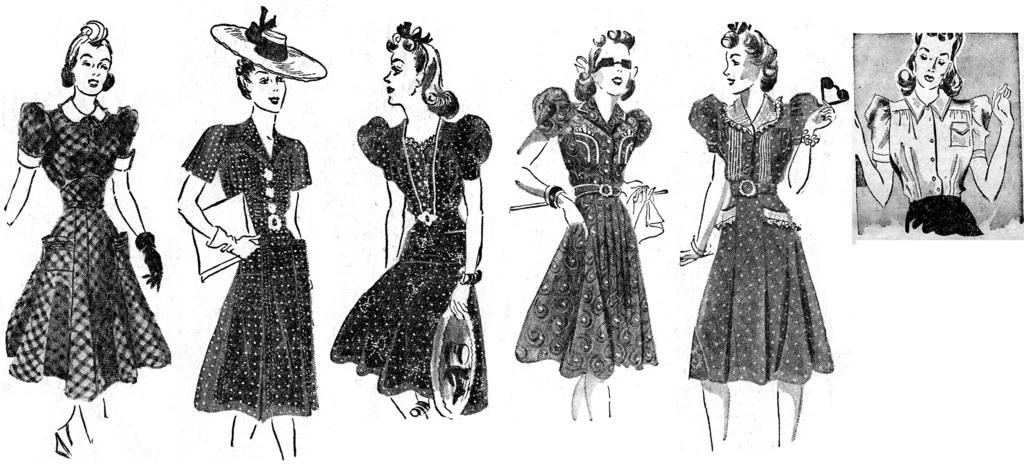What is depicted in the image? There are drawings of girls in the image. Can you describe the drawings in more detail? Unfortunately, the provided facts do not offer more details about the drawings. Are there any other elements in the image besides the drawings of girls? The provided facts do not mention any other elements in the image. What advice is the girl in the drawing giving to the viewer? There is no girl in the drawing giving advice to the viewer, as the provided facts only mention that there are drawings of girls in the image. 